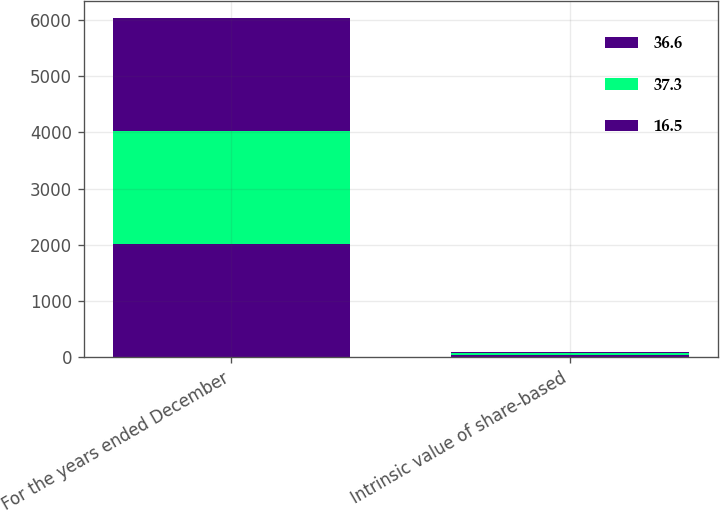Convert chart to OTSL. <chart><loc_0><loc_0><loc_500><loc_500><stacked_bar_chart><ecel><fcel>For the years ended December<fcel>Intrinsic value of share-based<nl><fcel>36.6<fcel>2012<fcel>37.3<nl><fcel>37.3<fcel>2011<fcel>36.6<nl><fcel>16.5<fcel>2010<fcel>16.5<nl></chart> 